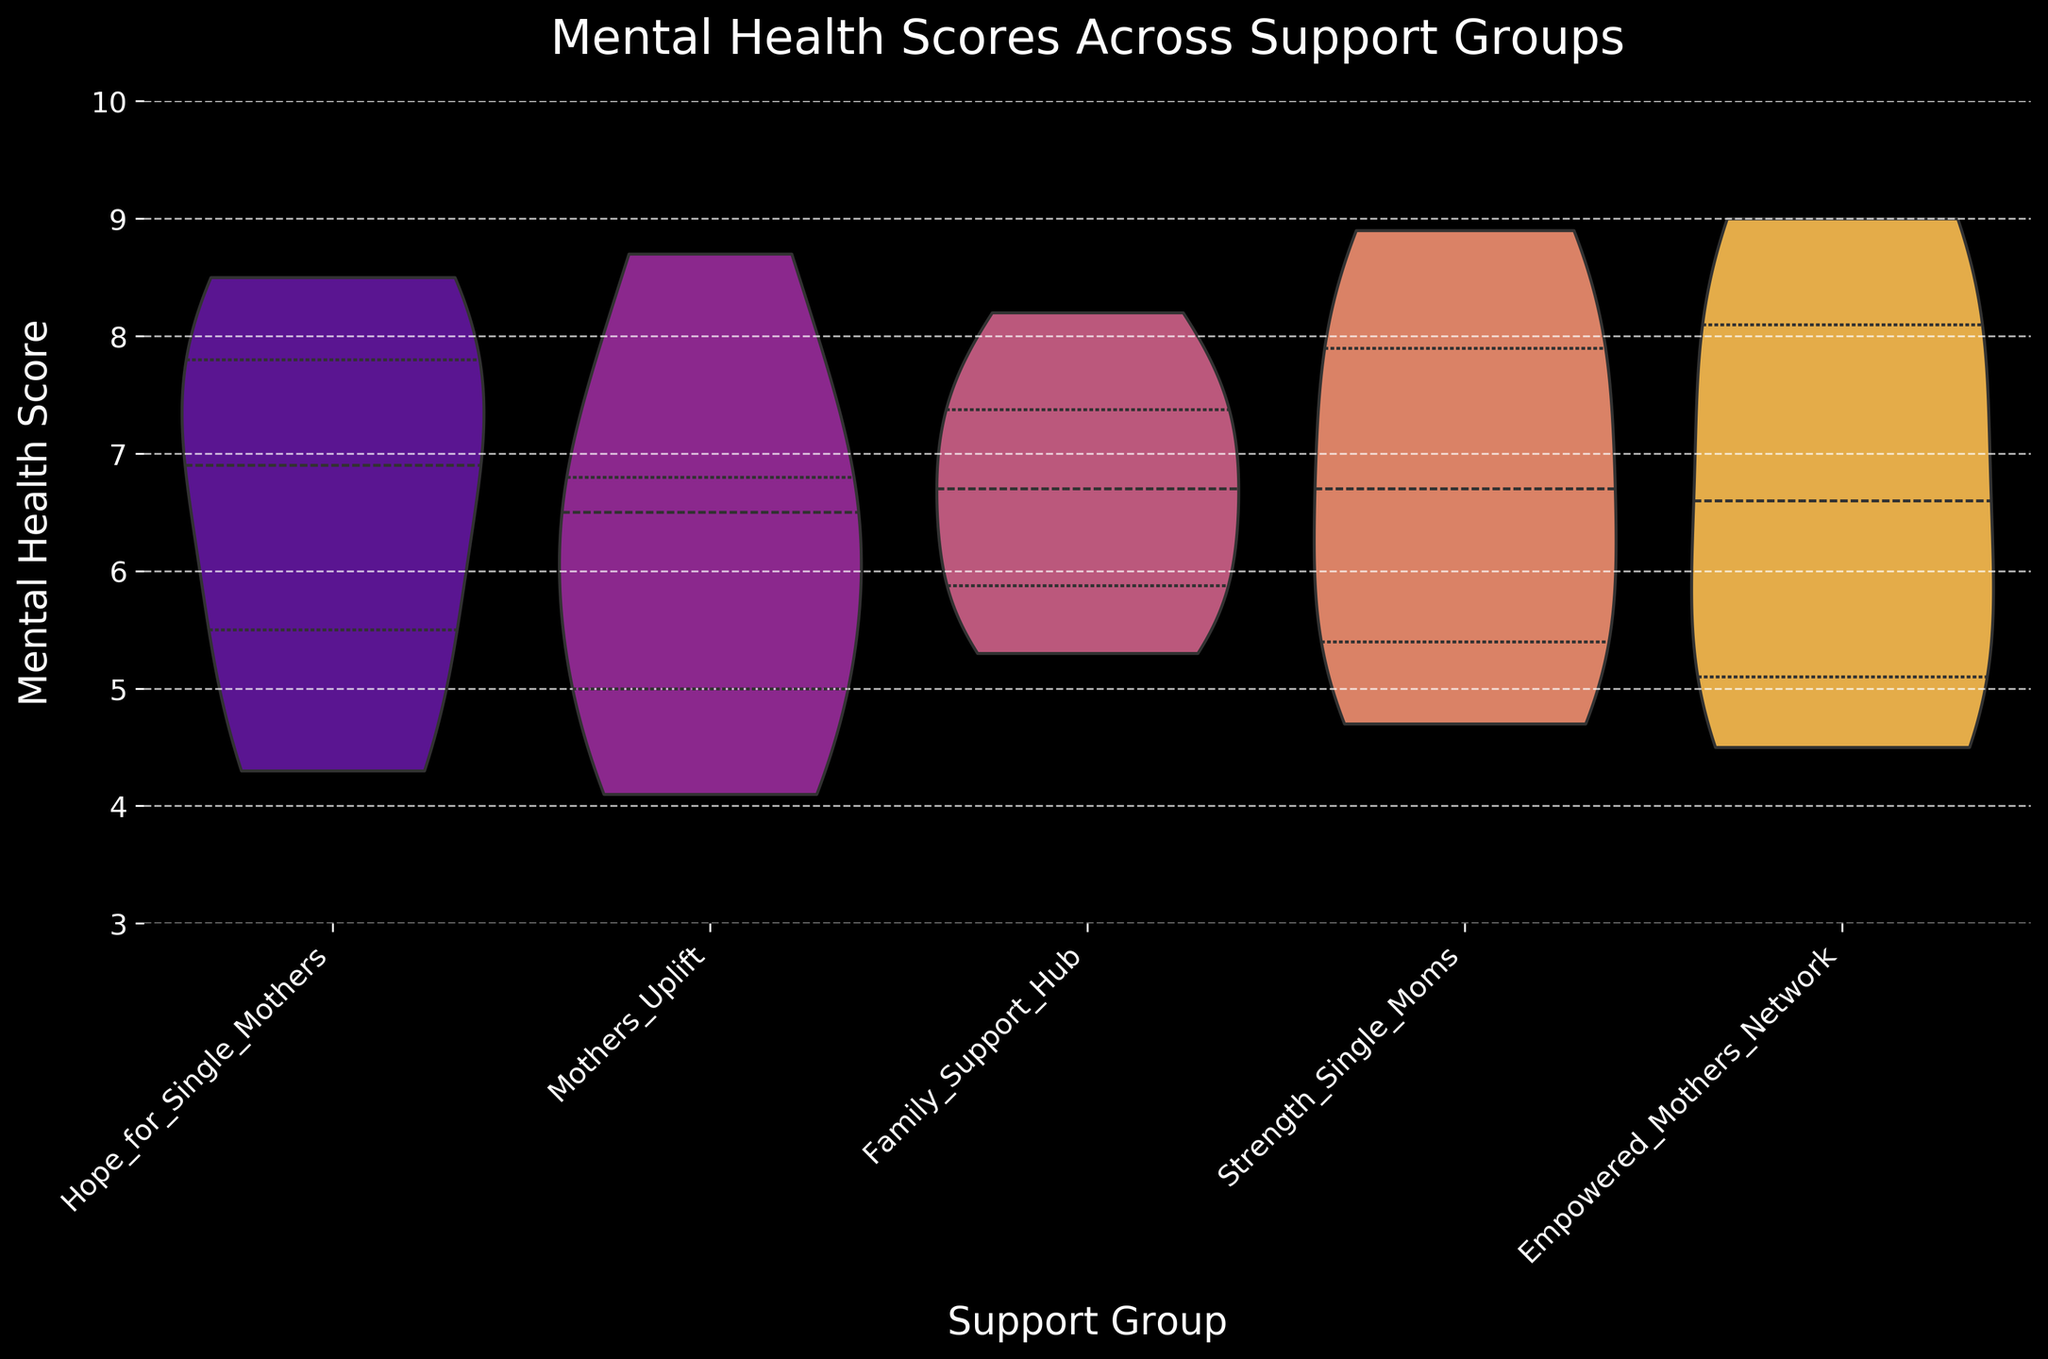What is the title of the chart? The title is positioned at the top center of the chart and provides a quick summary of what the data represents.
Answer: Mental Health Scores Across Support Groups What is the range of the y-axis? The y-axis range is indicated by the numerical labels along the y-axis which goes from the minimum to the maximum displayed value.
Answer: 3 to 10 Which support group shows the highest peak in mental health scores? By observing the peak regions within each violin plot, which represent the most frequent scores, we can identify the highest peak.
Answer: Empowered Mothers Network What is the shape of the distribution for the 'Low' level of support group 'Strength_Single_Moms'? Observing the 'Low' segment in the 'Strength_Single_Moms' violin plot, we can describe if it's wide, narrow, symmetric, or skewed.
Answer: Symmetric and slightly skewed to the lower end How do the mental health scores vary for 'Hope_for_Single_Mothers' across different support levels? By comparing the width and distribution of the 'Hope_for_Single_Mothers' violin plots for High, Medium, and Low support levels, we can discuss the spread and central tendency.
Answer: Scores are higher and more concentrated for high support and lower with more spread for low support Which support group has the widest distribution for 'Medium' level? Comparing the width of the 'Medium' violin plot for all support groups reveals which is the widest.
Answer: Family Support Hub Is there any support group where 'Low' and 'Medium' levels have similar distributions? Observing the violin plots for 'Low' and 'Medium' levels, we can compare their shapes and widths to identify similarities.
Answer: Mothers Uplift Are the mental health scores for 'High' support level consistent across all groups? By comparing the 'High' support level across all groups, we can infer whether the distributions and positions are similar or widely varied.
Answer: Generally consistent with some minor variations Which support group shows the most variation in 'Low' level mental health scores? The most variation can be determined by the widest and most spread-out 'Low' level violin plot.
Answer: Hope for Single Mothers 